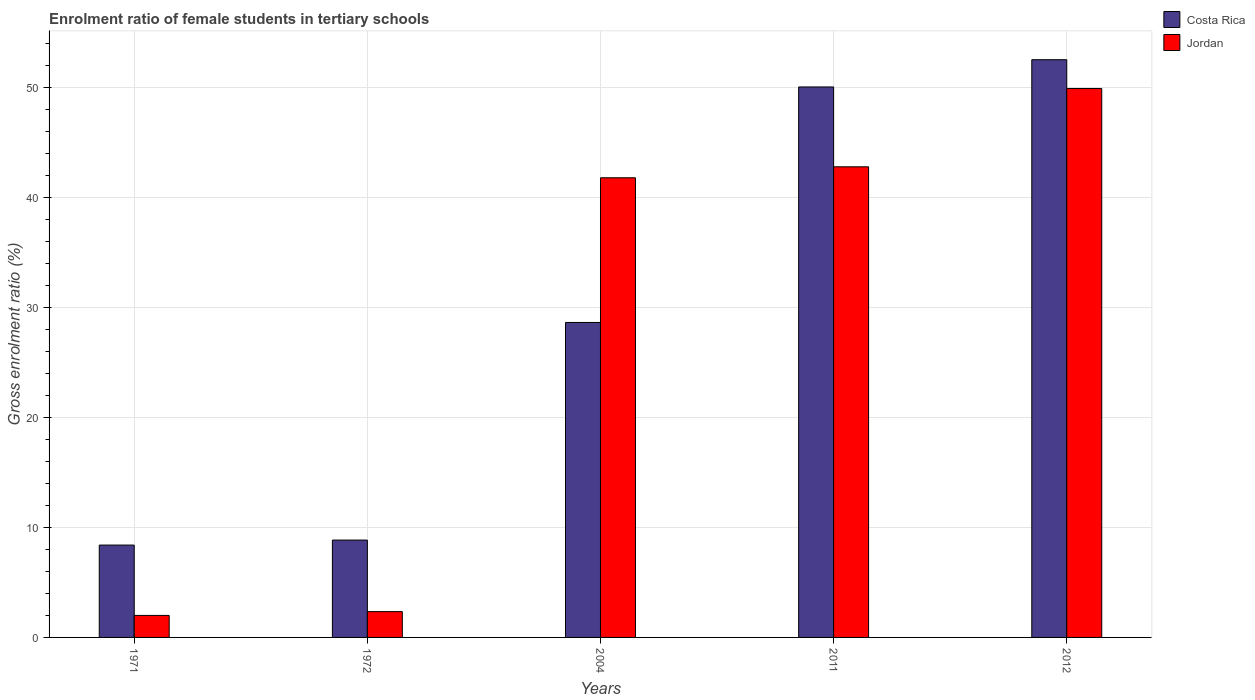How many groups of bars are there?
Offer a very short reply. 5. Are the number of bars on each tick of the X-axis equal?
Offer a very short reply. Yes. How many bars are there on the 5th tick from the left?
Your answer should be very brief. 2. In how many cases, is the number of bars for a given year not equal to the number of legend labels?
Keep it short and to the point. 0. What is the enrolment ratio of female students in tertiary schools in Costa Rica in 2004?
Offer a very short reply. 28.64. Across all years, what is the maximum enrolment ratio of female students in tertiary schools in Costa Rica?
Keep it short and to the point. 52.53. Across all years, what is the minimum enrolment ratio of female students in tertiary schools in Jordan?
Your answer should be very brief. 2. What is the total enrolment ratio of female students in tertiary schools in Jordan in the graph?
Your response must be concise. 138.85. What is the difference between the enrolment ratio of female students in tertiary schools in Jordan in 1972 and that in 2011?
Offer a terse response. -40.45. What is the difference between the enrolment ratio of female students in tertiary schools in Costa Rica in 1972 and the enrolment ratio of female students in tertiary schools in Jordan in 1971?
Offer a terse response. 6.85. What is the average enrolment ratio of female students in tertiary schools in Jordan per year?
Your answer should be very brief. 27.77. In the year 2004, what is the difference between the enrolment ratio of female students in tertiary schools in Costa Rica and enrolment ratio of female students in tertiary schools in Jordan?
Give a very brief answer. -13.16. In how many years, is the enrolment ratio of female students in tertiary schools in Costa Rica greater than 32 %?
Your response must be concise. 2. What is the ratio of the enrolment ratio of female students in tertiary schools in Costa Rica in 1972 to that in 2004?
Provide a short and direct response. 0.31. What is the difference between the highest and the second highest enrolment ratio of female students in tertiary schools in Costa Rica?
Provide a short and direct response. 2.48. What is the difference between the highest and the lowest enrolment ratio of female students in tertiary schools in Costa Rica?
Ensure brevity in your answer.  44.13. What does the 2nd bar from the right in 2004 represents?
Ensure brevity in your answer.  Costa Rica. How many bars are there?
Keep it short and to the point. 10. Are all the bars in the graph horizontal?
Provide a short and direct response. No. How many years are there in the graph?
Your response must be concise. 5. What is the difference between two consecutive major ticks on the Y-axis?
Offer a terse response. 10. Are the values on the major ticks of Y-axis written in scientific E-notation?
Your answer should be compact. No. Does the graph contain any zero values?
Make the answer very short. No. Where does the legend appear in the graph?
Provide a succinct answer. Top right. How many legend labels are there?
Make the answer very short. 2. What is the title of the graph?
Your answer should be very brief. Enrolment ratio of female students in tertiary schools. Does "Egypt, Arab Rep." appear as one of the legend labels in the graph?
Your answer should be very brief. No. What is the label or title of the X-axis?
Ensure brevity in your answer.  Years. What is the label or title of the Y-axis?
Your answer should be very brief. Gross enrolment ratio (%). What is the Gross enrolment ratio (%) in Costa Rica in 1971?
Make the answer very short. 8.4. What is the Gross enrolment ratio (%) in Jordan in 1971?
Your answer should be compact. 2. What is the Gross enrolment ratio (%) of Costa Rica in 1972?
Keep it short and to the point. 8.85. What is the Gross enrolment ratio (%) in Jordan in 1972?
Offer a very short reply. 2.35. What is the Gross enrolment ratio (%) of Costa Rica in 2004?
Make the answer very short. 28.64. What is the Gross enrolment ratio (%) of Jordan in 2004?
Provide a succinct answer. 41.8. What is the Gross enrolment ratio (%) in Costa Rica in 2011?
Keep it short and to the point. 50.05. What is the Gross enrolment ratio (%) in Jordan in 2011?
Keep it short and to the point. 42.79. What is the Gross enrolment ratio (%) of Costa Rica in 2012?
Make the answer very short. 52.53. What is the Gross enrolment ratio (%) of Jordan in 2012?
Make the answer very short. 49.92. Across all years, what is the maximum Gross enrolment ratio (%) in Costa Rica?
Keep it short and to the point. 52.53. Across all years, what is the maximum Gross enrolment ratio (%) in Jordan?
Provide a succinct answer. 49.92. Across all years, what is the minimum Gross enrolment ratio (%) in Costa Rica?
Make the answer very short. 8.4. Across all years, what is the minimum Gross enrolment ratio (%) in Jordan?
Your response must be concise. 2. What is the total Gross enrolment ratio (%) in Costa Rica in the graph?
Offer a very short reply. 148.48. What is the total Gross enrolment ratio (%) of Jordan in the graph?
Your answer should be compact. 138.85. What is the difference between the Gross enrolment ratio (%) of Costa Rica in 1971 and that in 1972?
Provide a short and direct response. -0.46. What is the difference between the Gross enrolment ratio (%) in Jordan in 1971 and that in 1972?
Provide a succinct answer. -0.35. What is the difference between the Gross enrolment ratio (%) of Costa Rica in 1971 and that in 2004?
Provide a short and direct response. -20.24. What is the difference between the Gross enrolment ratio (%) of Jordan in 1971 and that in 2004?
Make the answer very short. -39.79. What is the difference between the Gross enrolment ratio (%) of Costa Rica in 1971 and that in 2011?
Ensure brevity in your answer.  -41.66. What is the difference between the Gross enrolment ratio (%) of Jordan in 1971 and that in 2011?
Your response must be concise. -40.79. What is the difference between the Gross enrolment ratio (%) of Costa Rica in 1971 and that in 2012?
Your answer should be compact. -44.13. What is the difference between the Gross enrolment ratio (%) in Jordan in 1971 and that in 2012?
Your answer should be very brief. -47.92. What is the difference between the Gross enrolment ratio (%) of Costa Rica in 1972 and that in 2004?
Provide a succinct answer. -19.79. What is the difference between the Gross enrolment ratio (%) in Jordan in 1972 and that in 2004?
Provide a succinct answer. -39.45. What is the difference between the Gross enrolment ratio (%) in Costa Rica in 1972 and that in 2011?
Provide a succinct answer. -41.2. What is the difference between the Gross enrolment ratio (%) in Jordan in 1972 and that in 2011?
Your answer should be very brief. -40.45. What is the difference between the Gross enrolment ratio (%) in Costa Rica in 1972 and that in 2012?
Offer a very short reply. -43.68. What is the difference between the Gross enrolment ratio (%) in Jordan in 1972 and that in 2012?
Keep it short and to the point. -47.57. What is the difference between the Gross enrolment ratio (%) of Costa Rica in 2004 and that in 2011?
Your answer should be compact. -21.42. What is the difference between the Gross enrolment ratio (%) of Jordan in 2004 and that in 2011?
Your answer should be compact. -1. What is the difference between the Gross enrolment ratio (%) in Costa Rica in 2004 and that in 2012?
Offer a very short reply. -23.89. What is the difference between the Gross enrolment ratio (%) of Jordan in 2004 and that in 2012?
Ensure brevity in your answer.  -8.12. What is the difference between the Gross enrolment ratio (%) of Costa Rica in 2011 and that in 2012?
Provide a succinct answer. -2.48. What is the difference between the Gross enrolment ratio (%) in Jordan in 2011 and that in 2012?
Ensure brevity in your answer.  -7.12. What is the difference between the Gross enrolment ratio (%) of Costa Rica in 1971 and the Gross enrolment ratio (%) of Jordan in 1972?
Keep it short and to the point. 6.05. What is the difference between the Gross enrolment ratio (%) in Costa Rica in 1971 and the Gross enrolment ratio (%) in Jordan in 2004?
Give a very brief answer. -33.4. What is the difference between the Gross enrolment ratio (%) of Costa Rica in 1971 and the Gross enrolment ratio (%) of Jordan in 2011?
Your answer should be compact. -34.4. What is the difference between the Gross enrolment ratio (%) of Costa Rica in 1971 and the Gross enrolment ratio (%) of Jordan in 2012?
Keep it short and to the point. -41.52. What is the difference between the Gross enrolment ratio (%) in Costa Rica in 1972 and the Gross enrolment ratio (%) in Jordan in 2004?
Ensure brevity in your answer.  -32.94. What is the difference between the Gross enrolment ratio (%) of Costa Rica in 1972 and the Gross enrolment ratio (%) of Jordan in 2011?
Ensure brevity in your answer.  -33.94. What is the difference between the Gross enrolment ratio (%) in Costa Rica in 1972 and the Gross enrolment ratio (%) in Jordan in 2012?
Your response must be concise. -41.06. What is the difference between the Gross enrolment ratio (%) of Costa Rica in 2004 and the Gross enrolment ratio (%) of Jordan in 2011?
Provide a succinct answer. -14.15. What is the difference between the Gross enrolment ratio (%) in Costa Rica in 2004 and the Gross enrolment ratio (%) in Jordan in 2012?
Make the answer very short. -21.28. What is the difference between the Gross enrolment ratio (%) in Costa Rica in 2011 and the Gross enrolment ratio (%) in Jordan in 2012?
Ensure brevity in your answer.  0.14. What is the average Gross enrolment ratio (%) in Costa Rica per year?
Offer a terse response. 29.7. What is the average Gross enrolment ratio (%) in Jordan per year?
Give a very brief answer. 27.77. In the year 1971, what is the difference between the Gross enrolment ratio (%) of Costa Rica and Gross enrolment ratio (%) of Jordan?
Offer a terse response. 6.4. In the year 1972, what is the difference between the Gross enrolment ratio (%) in Costa Rica and Gross enrolment ratio (%) in Jordan?
Give a very brief answer. 6.51. In the year 2004, what is the difference between the Gross enrolment ratio (%) in Costa Rica and Gross enrolment ratio (%) in Jordan?
Keep it short and to the point. -13.16. In the year 2011, what is the difference between the Gross enrolment ratio (%) of Costa Rica and Gross enrolment ratio (%) of Jordan?
Offer a very short reply. 7.26. In the year 2012, what is the difference between the Gross enrolment ratio (%) of Costa Rica and Gross enrolment ratio (%) of Jordan?
Ensure brevity in your answer.  2.62. What is the ratio of the Gross enrolment ratio (%) of Costa Rica in 1971 to that in 1972?
Keep it short and to the point. 0.95. What is the ratio of the Gross enrolment ratio (%) in Jordan in 1971 to that in 1972?
Ensure brevity in your answer.  0.85. What is the ratio of the Gross enrolment ratio (%) of Costa Rica in 1971 to that in 2004?
Your response must be concise. 0.29. What is the ratio of the Gross enrolment ratio (%) in Jordan in 1971 to that in 2004?
Your answer should be very brief. 0.05. What is the ratio of the Gross enrolment ratio (%) of Costa Rica in 1971 to that in 2011?
Make the answer very short. 0.17. What is the ratio of the Gross enrolment ratio (%) in Jordan in 1971 to that in 2011?
Provide a short and direct response. 0.05. What is the ratio of the Gross enrolment ratio (%) of Costa Rica in 1971 to that in 2012?
Your answer should be very brief. 0.16. What is the ratio of the Gross enrolment ratio (%) in Jordan in 1971 to that in 2012?
Provide a short and direct response. 0.04. What is the ratio of the Gross enrolment ratio (%) of Costa Rica in 1972 to that in 2004?
Offer a terse response. 0.31. What is the ratio of the Gross enrolment ratio (%) in Jordan in 1972 to that in 2004?
Provide a short and direct response. 0.06. What is the ratio of the Gross enrolment ratio (%) of Costa Rica in 1972 to that in 2011?
Offer a very short reply. 0.18. What is the ratio of the Gross enrolment ratio (%) in Jordan in 1972 to that in 2011?
Give a very brief answer. 0.05. What is the ratio of the Gross enrolment ratio (%) of Costa Rica in 1972 to that in 2012?
Keep it short and to the point. 0.17. What is the ratio of the Gross enrolment ratio (%) of Jordan in 1972 to that in 2012?
Make the answer very short. 0.05. What is the ratio of the Gross enrolment ratio (%) of Costa Rica in 2004 to that in 2011?
Your response must be concise. 0.57. What is the ratio of the Gross enrolment ratio (%) of Jordan in 2004 to that in 2011?
Offer a very short reply. 0.98. What is the ratio of the Gross enrolment ratio (%) in Costa Rica in 2004 to that in 2012?
Provide a succinct answer. 0.55. What is the ratio of the Gross enrolment ratio (%) of Jordan in 2004 to that in 2012?
Give a very brief answer. 0.84. What is the ratio of the Gross enrolment ratio (%) of Costa Rica in 2011 to that in 2012?
Offer a very short reply. 0.95. What is the ratio of the Gross enrolment ratio (%) in Jordan in 2011 to that in 2012?
Give a very brief answer. 0.86. What is the difference between the highest and the second highest Gross enrolment ratio (%) in Costa Rica?
Give a very brief answer. 2.48. What is the difference between the highest and the second highest Gross enrolment ratio (%) in Jordan?
Provide a succinct answer. 7.12. What is the difference between the highest and the lowest Gross enrolment ratio (%) in Costa Rica?
Keep it short and to the point. 44.13. What is the difference between the highest and the lowest Gross enrolment ratio (%) in Jordan?
Provide a short and direct response. 47.92. 